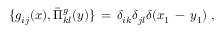Convert formula to latex. <formula><loc_0><loc_0><loc_500><loc_500>\{ g _ { i j } ( x ) , \bar { \Pi } _ { k l } ^ { g } ( y ) \} \, = \, \delta _ { i k } \delta _ { j l } \delta ( x _ { 1 } \, - \, y _ { 1 } ) \, ,</formula> 